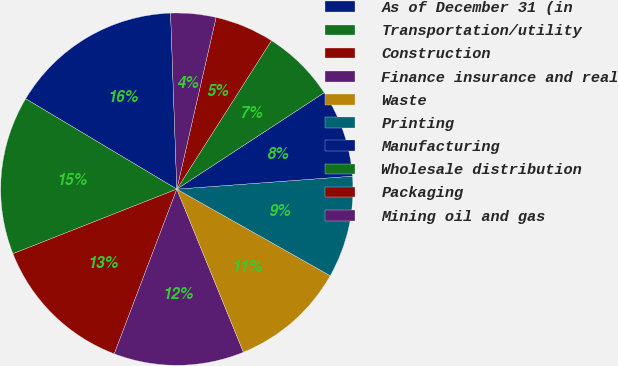Convert chart. <chart><loc_0><loc_0><loc_500><loc_500><pie_chart><fcel>As of December 31 (in<fcel>Transportation/utility<fcel>Construction<fcel>Finance insurance and real<fcel>Waste<fcel>Printing<fcel>Manufacturing<fcel>Wholesale distribution<fcel>Packaging<fcel>Mining oil and gas<nl><fcel>15.86%<fcel>14.55%<fcel>13.25%<fcel>11.95%<fcel>10.65%<fcel>9.35%<fcel>8.05%<fcel>6.75%<fcel>5.45%<fcel>4.14%<nl></chart> 